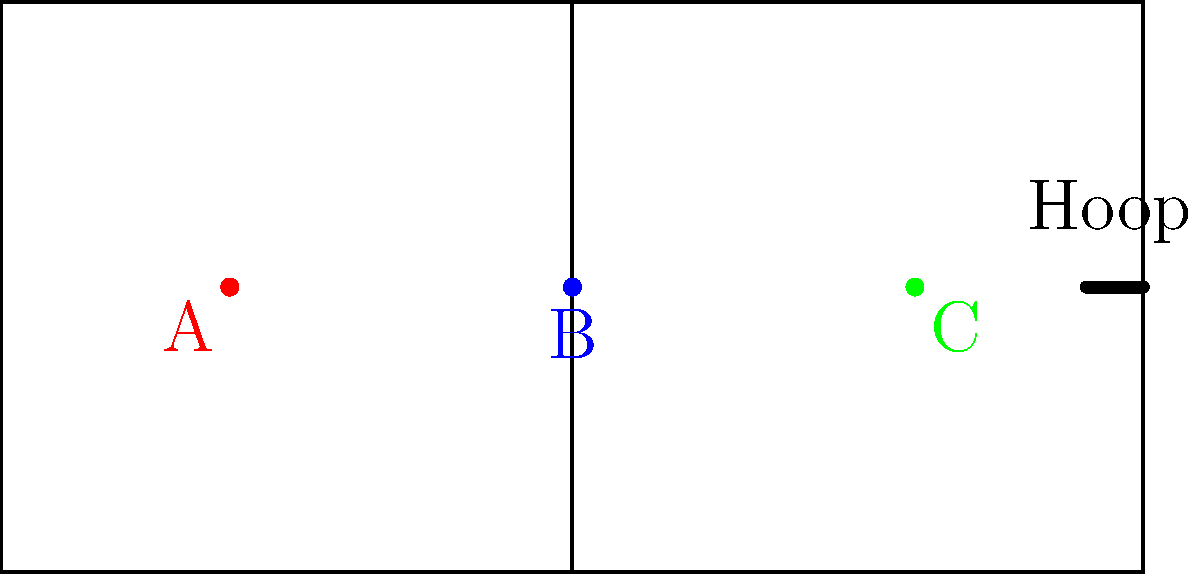As an aspiring professional basketball player, you're practicing slam dunks from different positions on the court. The diagram shows three starting positions (A, B, and C) for a slam dunk attempt. If the hoop is 3.05 meters (10 feet) high and you can jump 0.9 meters (3 feet) high, calculate the magnitude of the force vector needed to perform a successful slam dunk from position C, assuming your mass is 90 kg and neglecting air resistance. Use $g = 9.8 \text{ m/s}^2$. To calculate the force vector for a slam dunk from position C, we'll follow these steps:

1) First, calculate the horizontal distance from position C to the hoop:
   Distance = 20% of court width = 0.2 * 15.24 m = 3.048 m

2) Calculate the vertical distance needed to reach the hoop:
   Vertical distance = Hoop height - Jump height = 3.05 m - 0.9 m = 2.15 m

3) Use the equation of motion: $y = y_0 + v_0y t + \frac{1}{2} g t^2$
   Where $y = 2.15 \text{ m}$, $y_0 = 0 \text{ m}$, $g = -9.8 \text{ m/s}^2$

4) Solve for time $t$ using the horizontal motion: $x = v_0x t$
   $3.048 = v_0x t$, where $v_0x$ is the initial horizontal velocity

5) Substitute this into the vertical equation:
   $2.15 = v_0y (\frac{3.048}{v_0x}) - \frac{1}{2} (9.8) (\frac{3.048}{v_0x})^2$

6) Solve for $v_0y$ in terms of $v_0x$

7) Calculate the magnitude of the initial velocity vector:
   $v_0 = \sqrt{v_0x^2 + v_0y^2}$

8) Use Newton's Second Law to find the force:
   $F = ma = m\frac{v_0}{t} = 90 \cdot \frac{v_0}{3.048/v_0x}$

9) Substitute the values of $v_0x$ and $v_0y$ found earlier to get the magnitude of the force vector.
Answer: $$F \approx 1150 \text{ N}$$ 